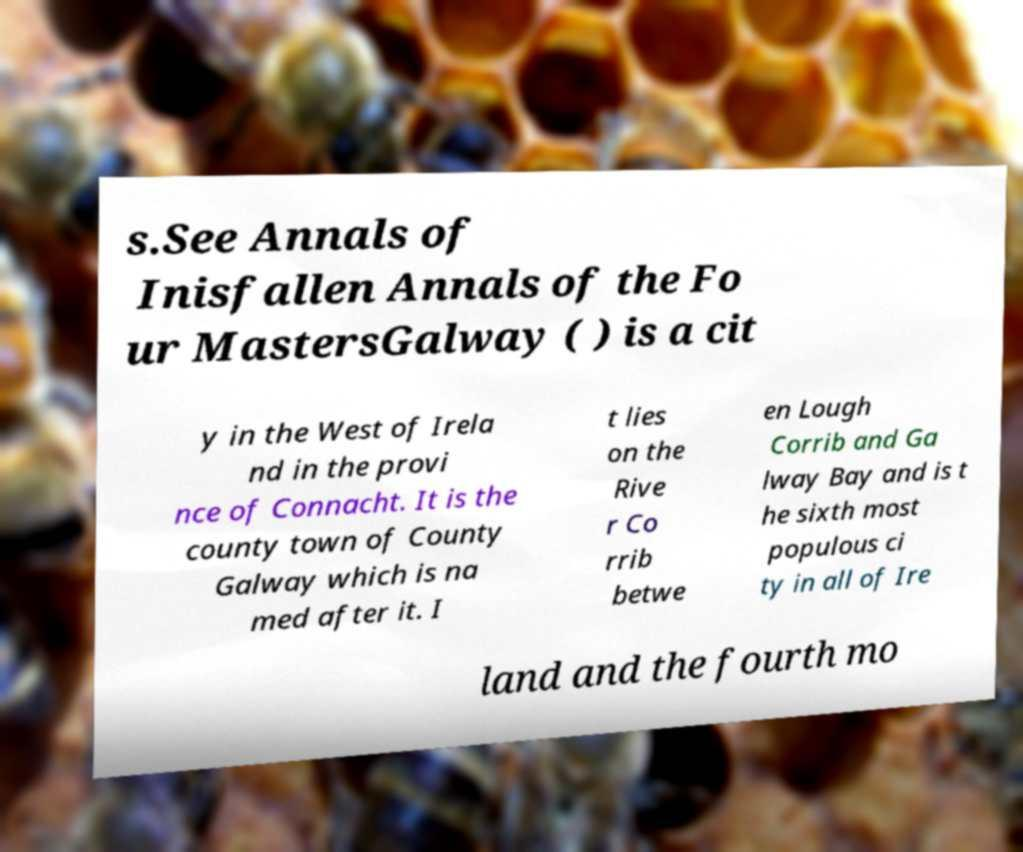For documentation purposes, I need the text within this image transcribed. Could you provide that? s.See Annals of Inisfallen Annals of the Fo ur MastersGalway ( ) is a cit y in the West of Irela nd in the provi nce of Connacht. It is the county town of County Galway which is na med after it. I t lies on the Rive r Co rrib betwe en Lough Corrib and Ga lway Bay and is t he sixth most populous ci ty in all of Ire land and the fourth mo 